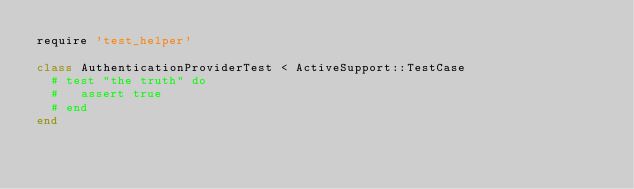<code> <loc_0><loc_0><loc_500><loc_500><_Ruby_>require 'test_helper'

class AuthenticationProviderTest < ActiveSupport::TestCase
  # test "the truth" do
  #   assert true
  # end
end
</code> 